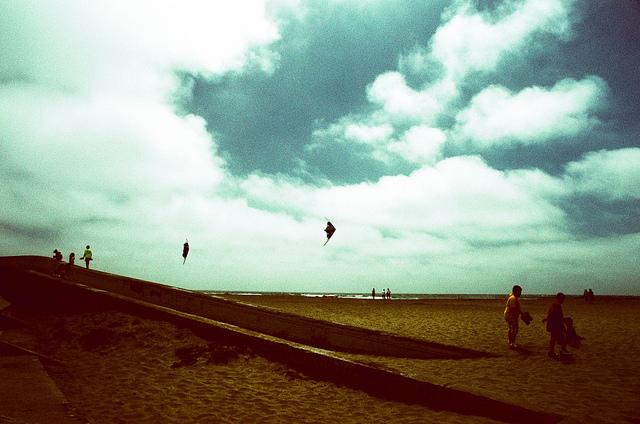Are there clouds?
Quick response, please. Yes. Where is this picture taken?
Keep it brief. Beach. What is flying in the sky?
Give a very brief answer. Kites. 